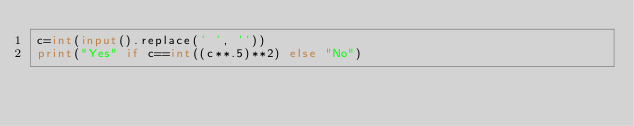<code> <loc_0><loc_0><loc_500><loc_500><_Python_>c=int(input().replace(' ', ''))
print("Yes" if c==int((c**.5)**2) else "No")</code> 